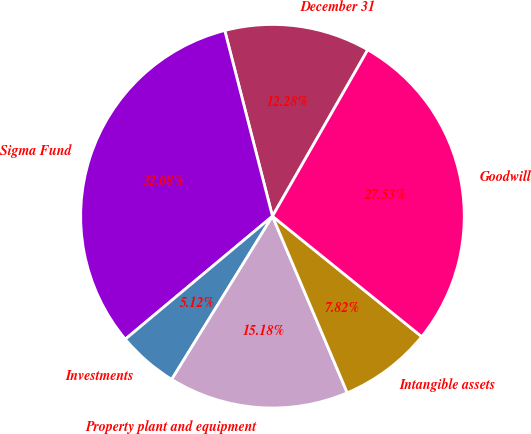<chart> <loc_0><loc_0><loc_500><loc_500><pie_chart><fcel>December 31<fcel>Sigma Fund<fcel>Investments<fcel>Property plant and equipment<fcel>Intangible assets<fcel>Goodwill<nl><fcel>12.28%<fcel>32.08%<fcel>5.12%<fcel>15.18%<fcel>7.82%<fcel>27.53%<nl></chart> 